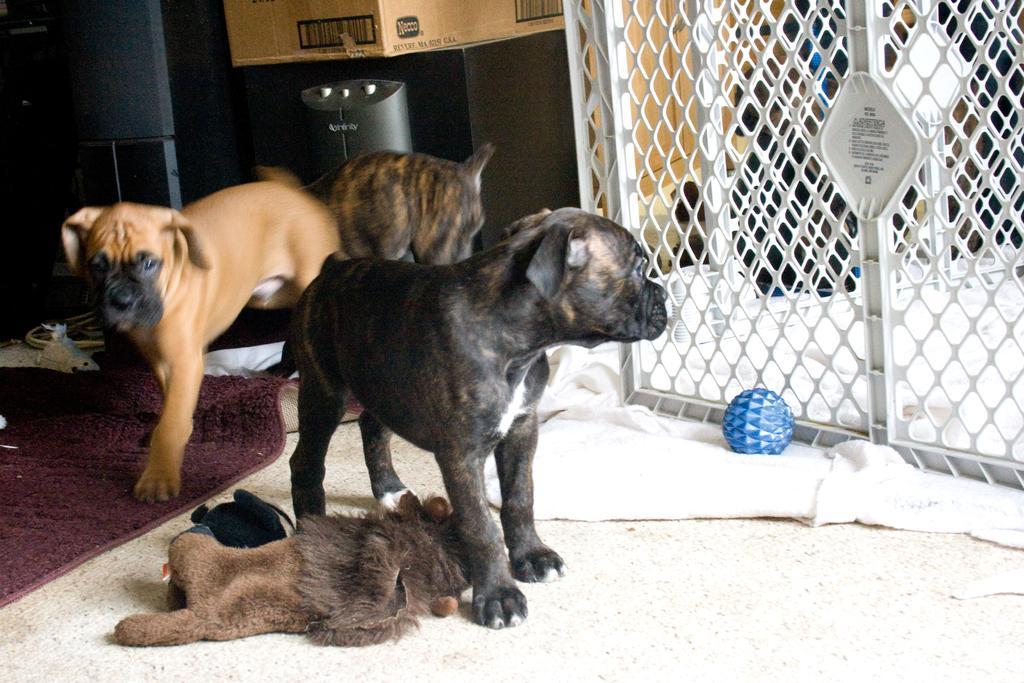Describe this image in one or two sentences. In this image I can see few dogs and colour of these dogs are black, brown and cream. I can also see a maroon colour floor mattress, a brown colour soft toy, a blue ball, few white colour clothes, a box and few other stuffs in the background. 